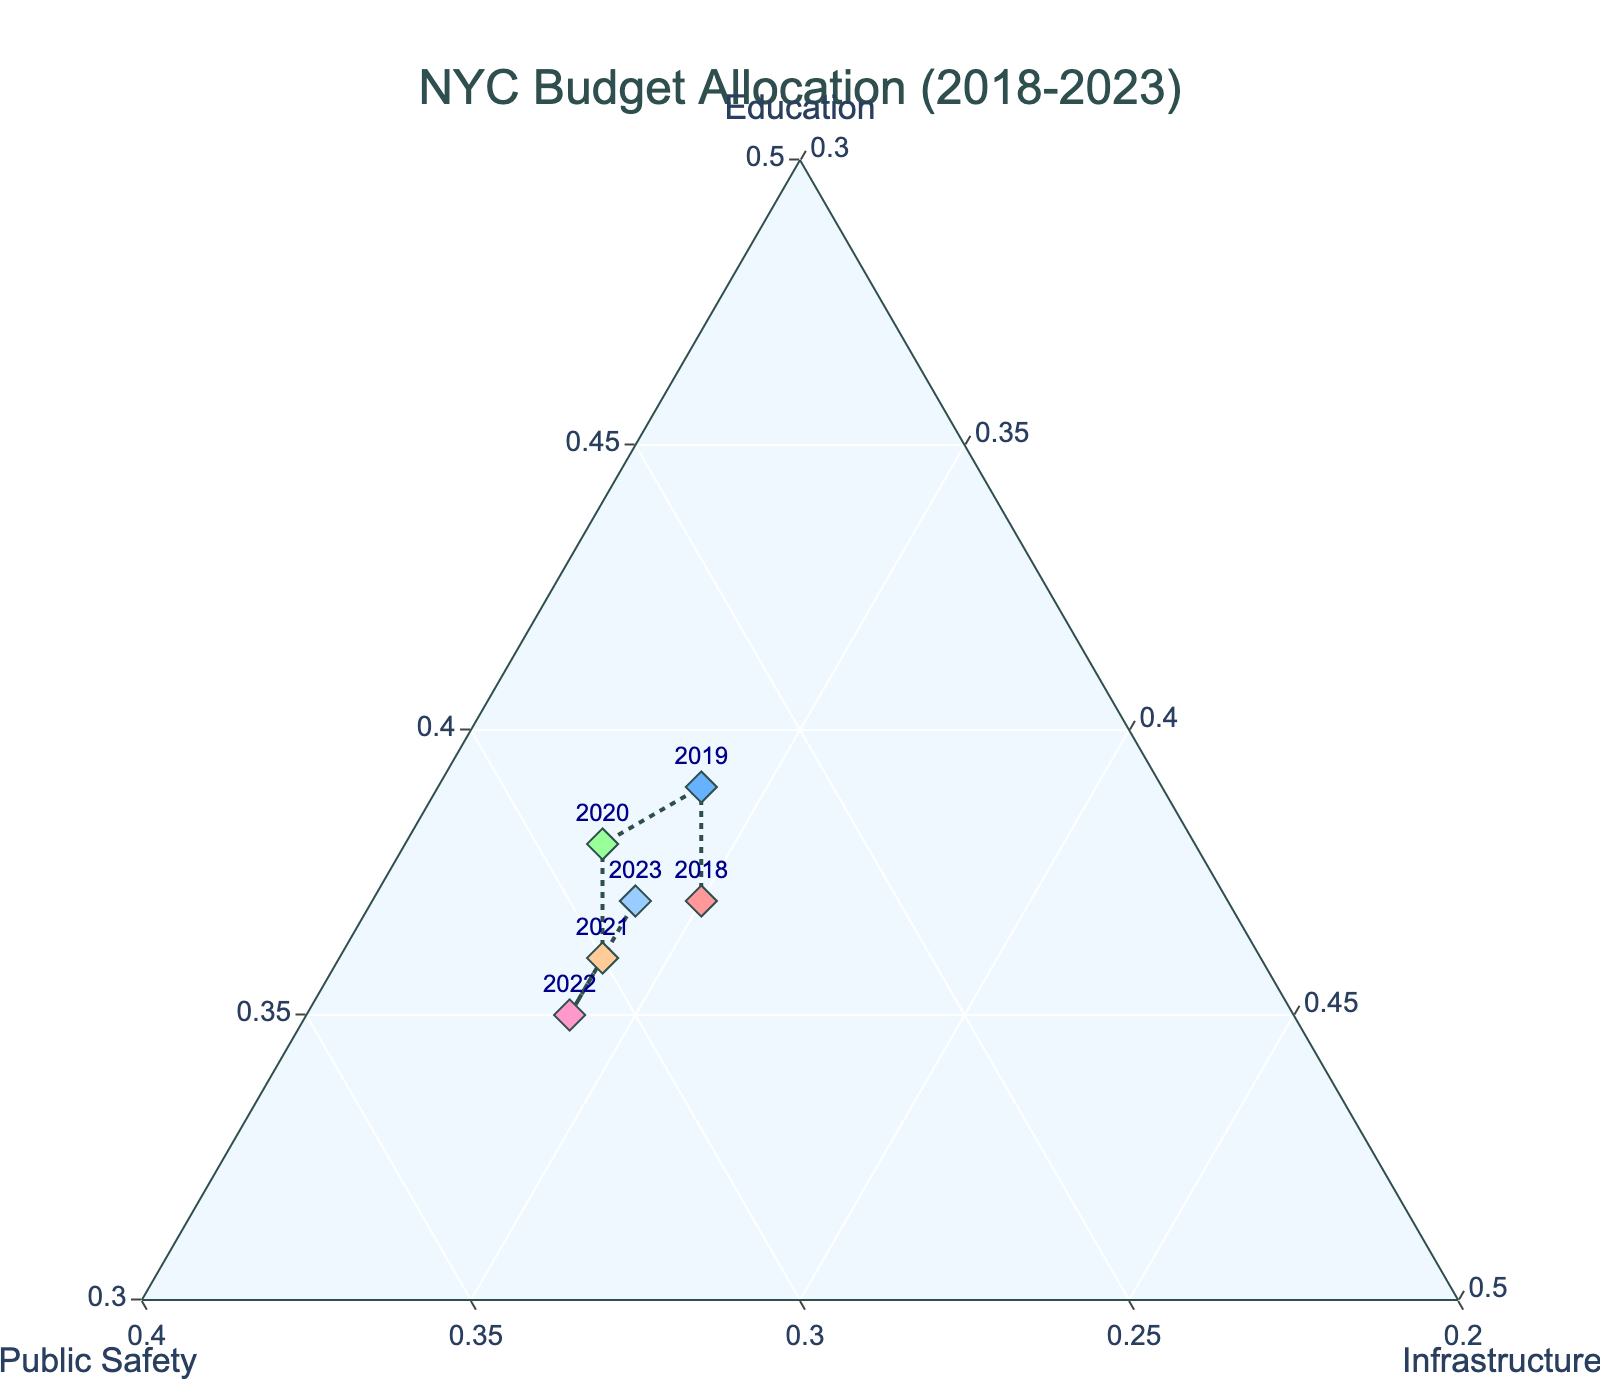What is the title of the figure? The title is usually displayed at the top of the figure, providing a concise description of what the figure represents. In this case, the title "NYC Budget Allocation (2018-2023)" is found centered at the top of the plot.
Answer: NYC Budget Allocation (2018-2023) How many data points are plotted in the Ternary Plot? The legend or labels in the plot show one data point for each year from 2018 to 2023. Counting these points, we see there are six data points.
Answer: 6 Which category has the highest minimum axis value? Each Ternary Plot axis has a minimum value. Looking at the plot, the minimum values are as follows - Education: 30, Public Safety: 20, Infrastructure: 30. By comparing these, Public Safety has the highest minimum at 20.
Answer: Education and Infrastructure (both 30) In which year was the percentage allocated to Education the highest? By examining the data points and their associated labels on the Education axis, the highest value for Education is 39%, which occurred in the year 2019.
Answer: 2019 Which category experienced the most increase in allocation from 2018 to 2022? To determine the category with the most increase, compare the values from 2018 to 2022. For Education, it decreased from 37% to 35% (-2%). For Public Safety, it increased from 28% to 31% (+3%). For Infrastructure, it remained constant at 34%. Public Safety has the highest increase (+3%).
Answer: Public Safety What is the average allocation in percentages for Infrastructure from 2018 to 2023? The values for Infrastructure are 35, 34, 33, 34, 34, and 34. Summing them gives 204 and dividing by 6 data points gives an average of 34.
Answer: 34% Which two categories have the closest allocations in 2021? Looking at the year 2021, the allocations are 36% for Education, 30% for Public Safety, and 34% for Infrastructure. The difference between Education and Infrastructure is 2%, which is the smallest difference.
Answer: Education and Infrastructure In which year were the allocations for Public Safety and Infrastructure equal? By examining the data points year-by-year,  we can see that the allocations for Public Safety and Infrastructure were never exactly equal in any year mentioned.
Answer: None Is there any year where the budget allocation for Education decreased compared to the previous year? By comparing Education budgets from year to year: 2018 to 2019 sees an increase, 2019 to 2020 sees a decrease (from 39% to 38%), 2020 to 2021 sees another decrease (from 38% to 36%). Thus, there are years with a decrease in Education allocation.
Answer: Yes, 2020 and 2021 What is the dominant category in 2020? In 2020, the values are Education: 38%, Public Safety: 29%, Infrastructure: 33%. Education has the highest allocation.
Answer: Education 